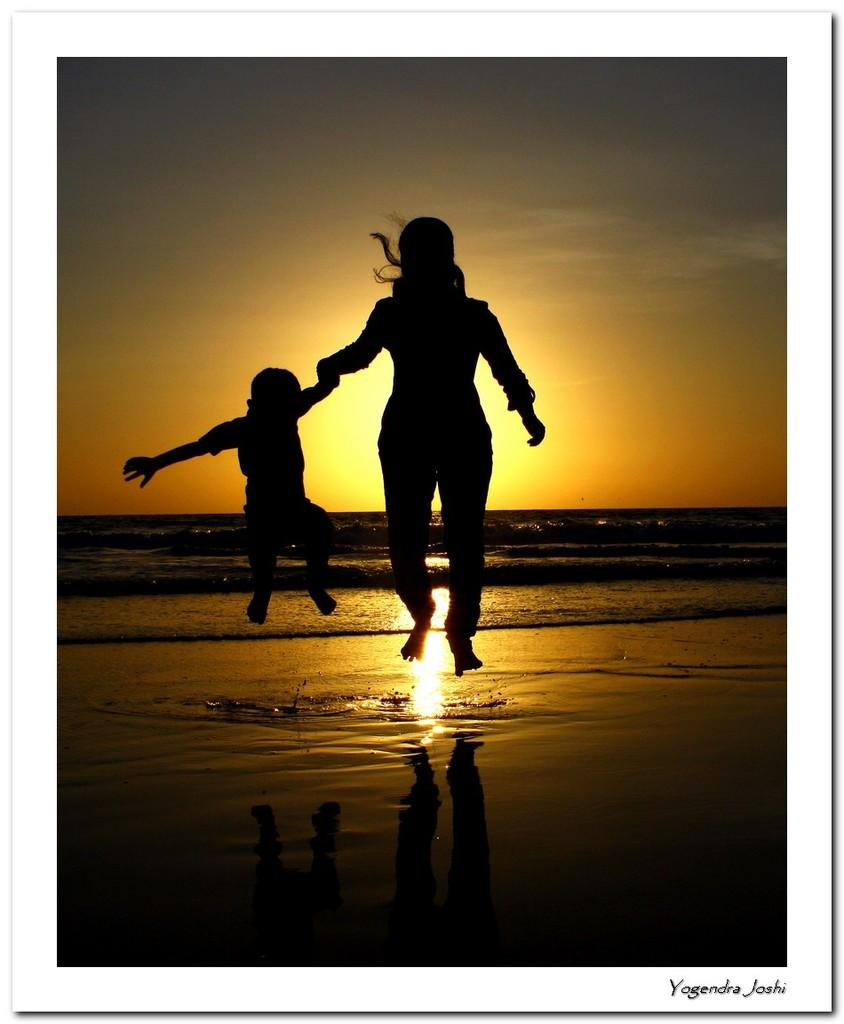Who is present in the image? There is a woman and a kid in the image. What are the woman and the kid doing in the image? Both the woman and the kid are jumping on a seashore. What can be seen in the background of the image? There is a sea visible in the background of the image, and there is a sunrise in the sky. Is there any text present in the image? Yes, there is text present in the bottom right corner of the image. What type of connection can be seen between the woman and the kid in the image? There is no specific connection between the woman and the kid mentioned in the image; they are simply both jumping on a seashore. What form does the sunrise take in the image? The sunrise is not described in terms of form in the image; it is simply mentioned as being present in the sky. 